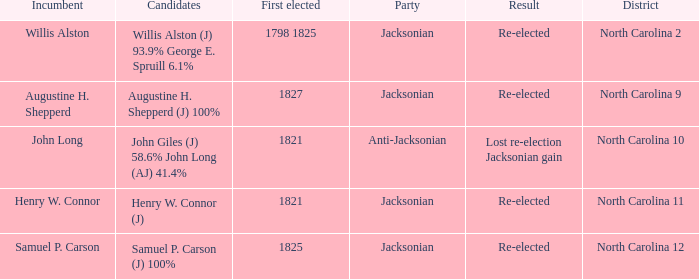Name the district for anti-jacksonian North Carolina 10. 